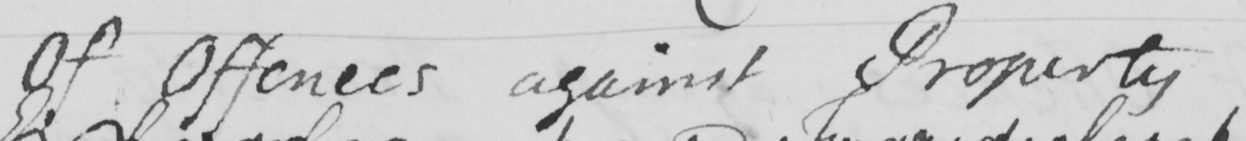Please provide the text content of this handwritten line. Of Offences against Property 